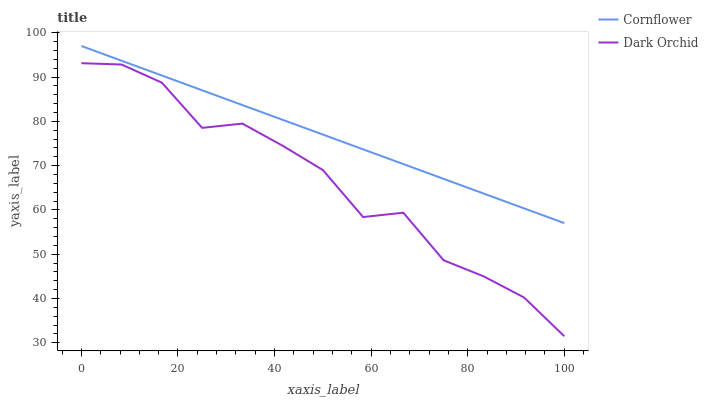Does Dark Orchid have the minimum area under the curve?
Answer yes or no. Yes. Does Cornflower have the maximum area under the curve?
Answer yes or no. Yes. Does Dark Orchid have the maximum area under the curve?
Answer yes or no. No. Is Cornflower the smoothest?
Answer yes or no. Yes. Is Dark Orchid the roughest?
Answer yes or no. Yes. Is Dark Orchid the smoothest?
Answer yes or no. No. Does Cornflower have the highest value?
Answer yes or no. Yes. Does Dark Orchid have the highest value?
Answer yes or no. No. Is Dark Orchid less than Cornflower?
Answer yes or no. Yes. Is Cornflower greater than Dark Orchid?
Answer yes or no. Yes. Does Dark Orchid intersect Cornflower?
Answer yes or no. No. 